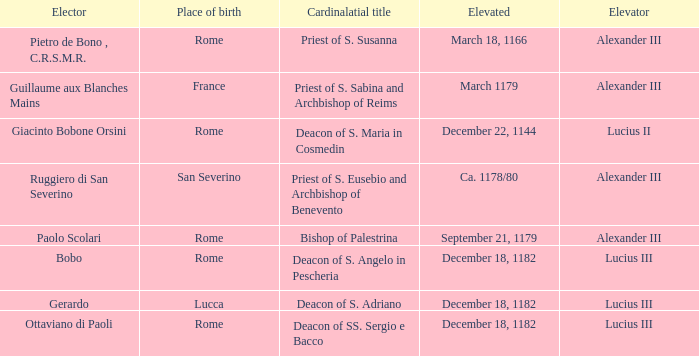What Elector has an Elevator of Alexander III and a Cardinalatial title of Bishop of Palestrina? Paolo Scolari. 